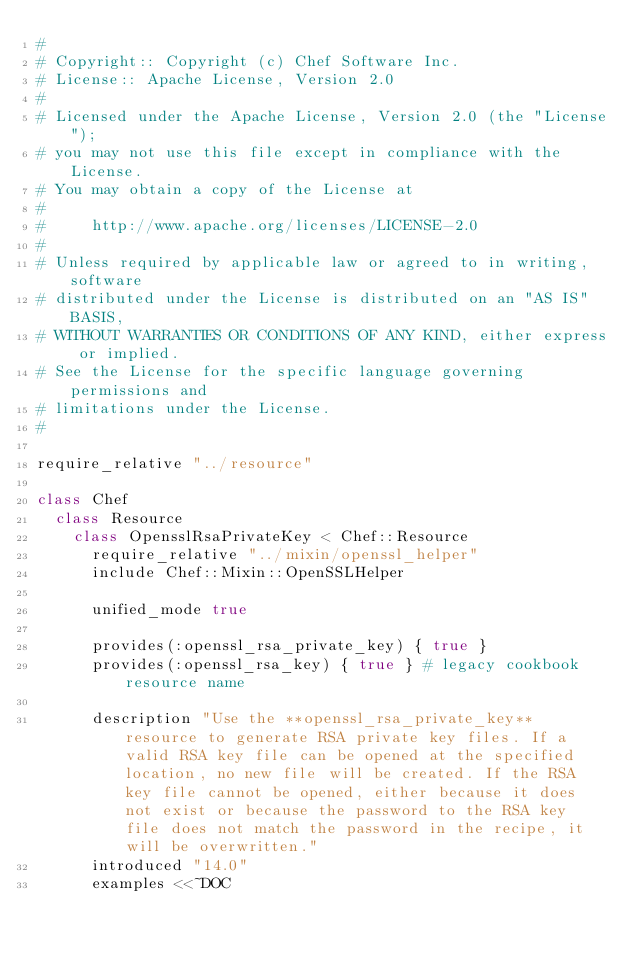<code> <loc_0><loc_0><loc_500><loc_500><_Ruby_>#
# Copyright:: Copyright (c) Chef Software Inc.
# License:: Apache License, Version 2.0
#
# Licensed under the Apache License, Version 2.0 (the "License");
# you may not use this file except in compliance with the License.
# You may obtain a copy of the License at
#
#     http://www.apache.org/licenses/LICENSE-2.0
#
# Unless required by applicable law or agreed to in writing, software
# distributed under the License is distributed on an "AS IS" BASIS,
# WITHOUT WARRANTIES OR CONDITIONS OF ANY KIND, either express or implied.
# See the License for the specific language governing permissions and
# limitations under the License.
#

require_relative "../resource"

class Chef
  class Resource
    class OpensslRsaPrivateKey < Chef::Resource
      require_relative "../mixin/openssl_helper"
      include Chef::Mixin::OpenSSLHelper

      unified_mode true

      provides(:openssl_rsa_private_key) { true }
      provides(:openssl_rsa_key) { true } # legacy cookbook resource name

      description "Use the **openssl_rsa_private_key** resource to generate RSA private key files. If a valid RSA key file can be opened at the specified location, no new file will be created. If the RSA key file cannot be opened, either because it does not exist or because the password to the RSA key file does not match the password in the recipe, it will be overwritten."
      introduced "14.0"
      examples <<~DOC</code> 